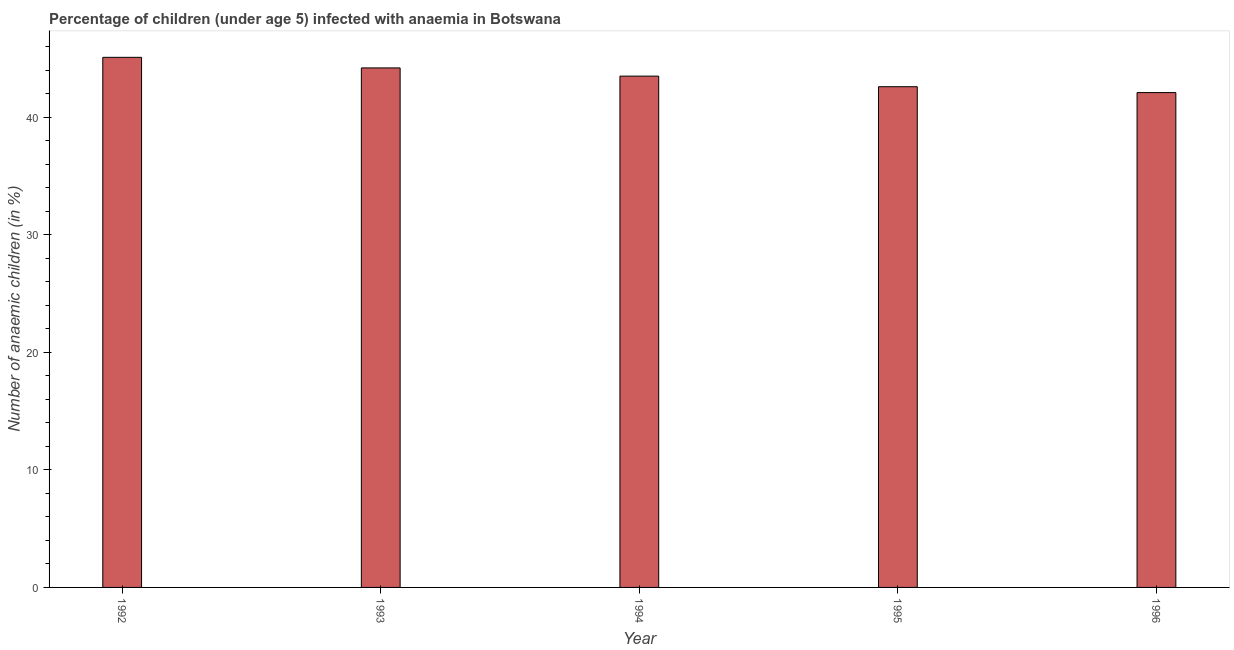Does the graph contain any zero values?
Offer a terse response. No. Does the graph contain grids?
Your response must be concise. No. What is the title of the graph?
Offer a terse response. Percentage of children (under age 5) infected with anaemia in Botswana. What is the label or title of the Y-axis?
Your answer should be very brief. Number of anaemic children (in %). What is the number of anaemic children in 1994?
Your response must be concise. 43.5. Across all years, what is the maximum number of anaemic children?
Provide a succinct answer. 45.1. Across all years, what is the minimum number of anaemic children?
Your response must be concise. 42.1. In which year was the number of anaemic children maximum?
Offer a very short reply. 1992. What is the sum of the number of anaemic children?
Your response must be concise. 217.5. What is the average number of anaemic children per year?
Keep it short and to the point. 43.5. What is the median number of anaemic children?
Provide a succinct answer. 43.5. Do a majority of the years between 1993 and 1995 (inclusive) have number of anaemic children greater than 36 %?
Keep it short and to the point. Yes. Is the number of anaemic children in 1994 less than that in 1996?
Your response must be concise. No. Is the difference between the number of anaemic children in 1992 and 1995 greater than the difference between any two years?
Your answer should be very brief. No. Is the sum of the number of anaemic children in 1993 and 1994 greater than the maximum number of anaemic children across all years?
Make the answer very short. Yes. How many bars are there?
Give a very brief answer. 5. What is the difference between two consecutive major ticks on the Y-axis?
Ensure brevity in your answer.  10. What is the Number of anaemic children (in %) in 1992?
Keep it short and to the point. 45.1. What is the Number of anaemic children (in %) of 1993?
Keep it short and to the point. 44.2. What is the Number of anaemic children (in %) in 1994?
Your answer should be compact. 43.5. What is the Number of anaemic children (in %) of 1995?
Make the answer very short. 42.6. What is the Number of anaemic children (in %) in 1996?
Your answer should be compact. 42.1. What is the difference between the Number of anaemic children (in %) in 1992 and 1994?
Your answer should be compact. 1.6. What is the difference between the Number of anaemic children (in %) in 1993 and 1994?
Your response must be concise. 0.7. What is the difference between the Number of anaemic children (in %) in 1995 and 1996?
Give a very brief answer. 0.5. What is the ratio of the Number of anaemic children (in %) in 1992 to that in 1995?
Your answer should be very brief. 1.06. What is the ratio of the Number of anaemic children (in %) in 1992 to that in 1996?
Your answer should be very brief. 1.07. What is the ratio of the Number of anaemic children (in %) in 1993 to that in 1995?
Your answer should be compact. 1.04. What is the ratio of the Number of anaemic children (in %) in 1994 to that in 1996?
Offer a terse response. 1.03. 